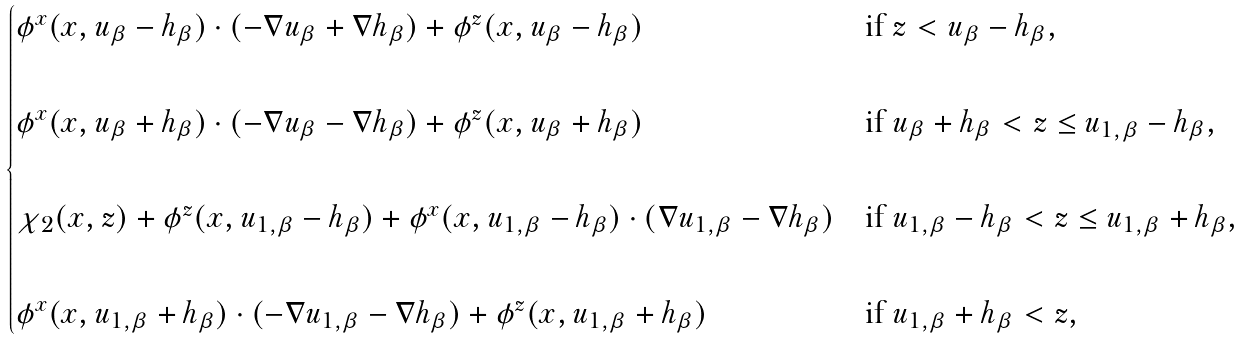Convert formula to latex. <formula><loc_0><loc_0><loc_500><loc_500>\begin{cases} \phi ^ { x } ( x , u _ { \beta } - h _ { \beta } ) \cdot ( - \nabla u _ { \beta } + \nabla h _ { \beta } ) + \phi ^ { z } ( x , u _ { \beta } - h _ { \beta } ) & \text {if $z<u_{\beta}-h_{\beta}$,} \\ \\ \phi ^ { x } ( x , u _ { \beta } + h _ { \beta } ) \cdot ( - \nabla u _ { \beta } - \nabla h _ { \beta } ) + \phi ^ { z } ( x , u _ { \beta } + h _ { \beta } ) & \text {if $u_{\beta}+h_{\beta}<z\leq u_{1,\beta}-h_{\beta}$,} \\ \\ \chi _ { 2 } ( x , z ) + \phi ^ { z } ( x , u _ { 1 , \beta } - h _ { \beta } ) + \phi ^ { x } ( x , u _ { 1 , \beta } - h _ { \beta } ) \cdot ( \nabla u _ { 1 , \beta } - \nabla h _ { \beta } ) & \text {if $u_{1,\beta}-h_{\beta}<z\leq u_{1,\beta}+h_{\beta}$,} \\ \\ \phi ^ { x } ( x , u _ { 1 , \beta } + h _ { \beta } ) \cdot ( - \nabla u _ { 1 , \beta } - \nabla h _ { \beta } ) + \phi ^ { z } ( x , u _ { 1 , \beta } + h _ { \beta } ) & \text {if $u_{1,\beta}+h_{\beta}<z$,} \end{cases}</formula> 